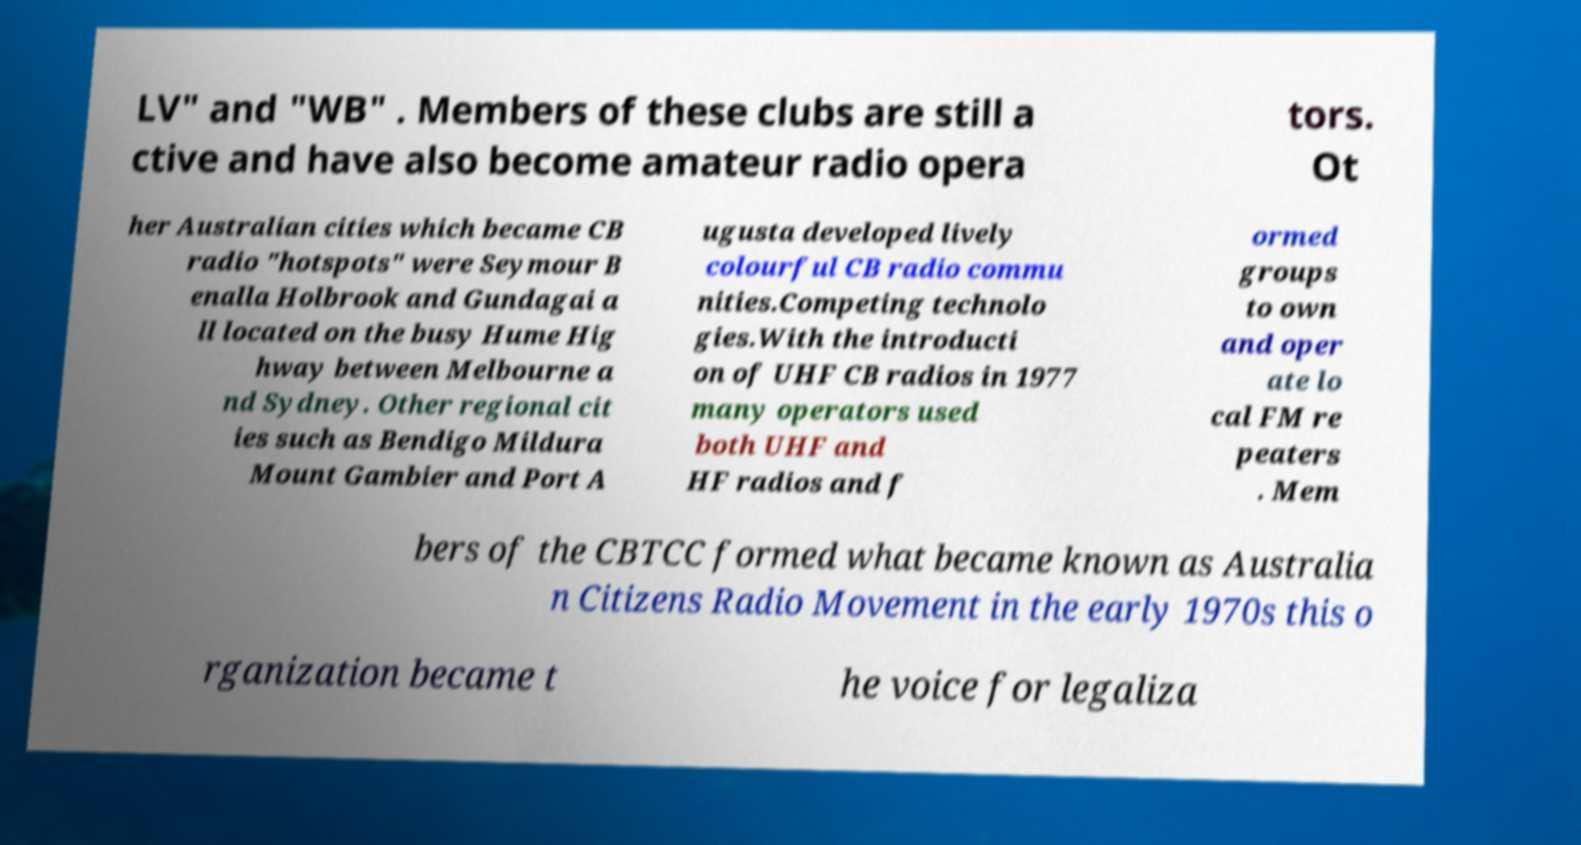Please identify and transcribe the text found in this image. LV" and "WB" . Members of these clubs are still a ctive and have also become amateur radio opera tors. Ot her Australian cities which became CB radio "hotspots" were Seymour B enalla Holbrook and Gundagai a ll located on the busy Hume Hig hway between Melbourne a nd Sydney. Other regional cit ies such as Bendigo Mildura Mount Gambier and Port A ugusta developed lively colourful CB radio commu nities.Competing technolo gies.With the introducti on of UHF CB radios in 1977 many operators used both UHF and HF radios and f ormed groups to own and oper ate lo cal FM re peaters . Mem bers of the CBTCC formed what became known as Australia n Citizens Radio Movement in the early 1970s this o rganization became t he voice for legaliza 